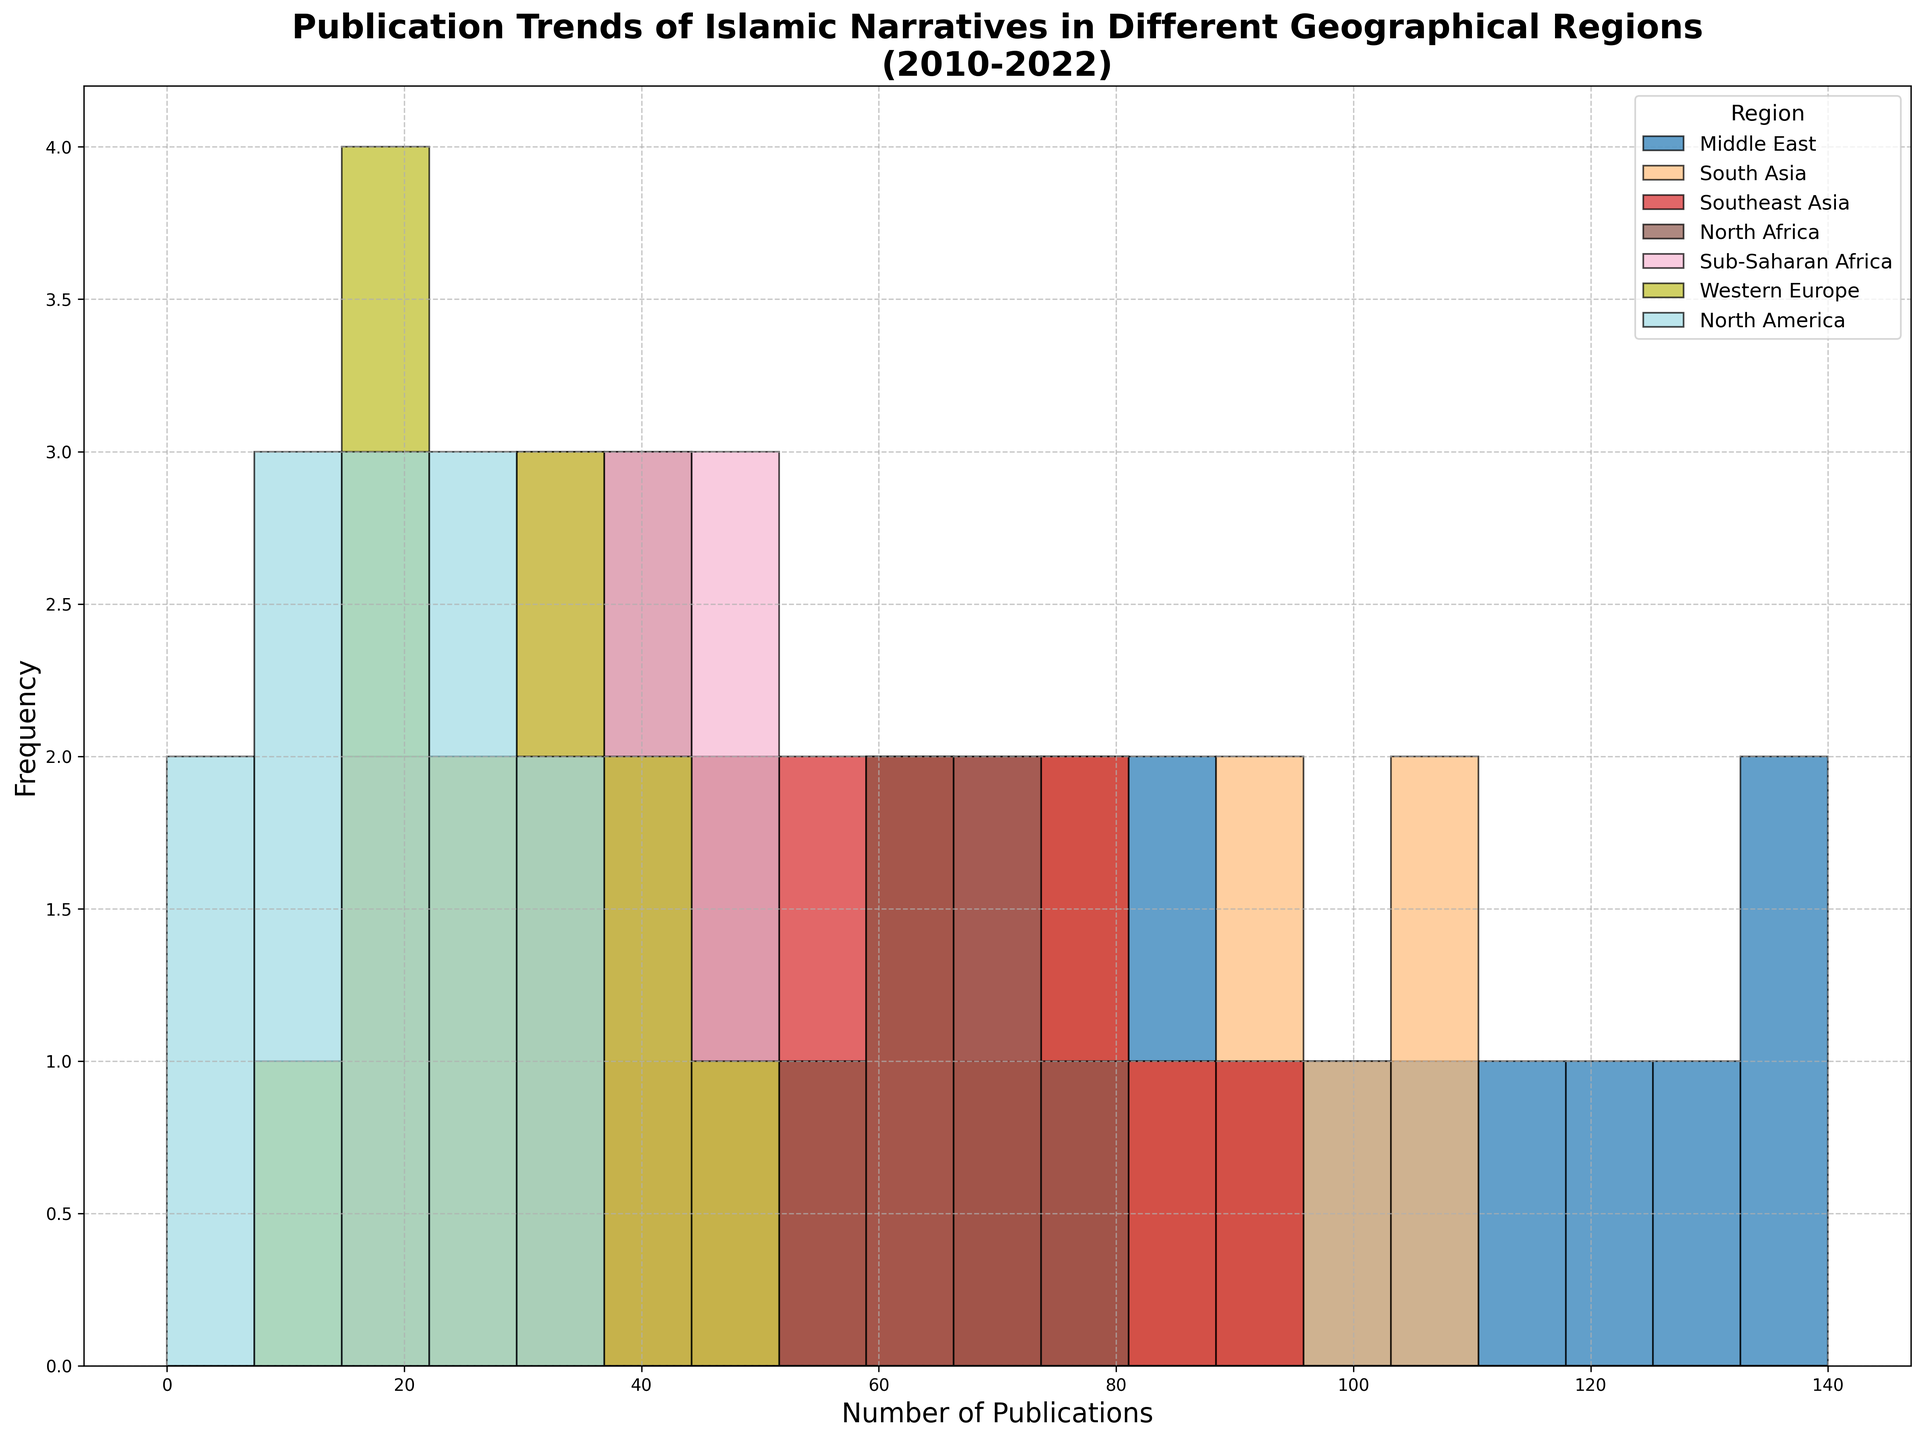What's the most frequent range of publications for the Middle East? To find the most frequent range, observe the height (frequency) of the bins in the histogram for the Middle East. Identify the bin with the highest bar (peak) for that region.
Answer: 120-140 Which region has the second-highest number of publications in the 2010-2022 timeframe? Compare the max number of publications for different regions from the histogram. The Middle East has the highest peak at 140, followed by South Asia with a peak at 110.
Answer: South Asia Is there any region that has a consistently low publication frequency over the years? Look at all the bins with the shortest bars across the entire plot. Western Europe and North America have much lower frequencies compared to others.
Answer: Western Europe and North America What is the range of publications for North Africa? Observe the x-axis range where there are bars representing North Africa. This range starts from the minimum number of publications and ends with the maximum.
Answer: 30-75 Which region shows the highest growth in publications over the years? By comparing the trends in the histogram, look for the region where bars shift significantly rightwards over time. The Middle East shows substantial growth, moving up to 140 publications.
Answer: Middle East What's the least number of publications recorded in Southeast Asia? Find the shortest bar for Southeast Asia on the histogram. This corresponds to the least number of publications.
Answer: 40 Compare the variability in publication trends between Sub-Saharan Africa and North America. Look at the spread of bars for both regions. Sub-Saharan Africa ranges from 20 to 50 while North America ranges from 5 to 35. Assess the spread and the increase in publication counts.
Answer: Sub-Saharan Africa has more variability Which two regions have publication ranges that overlap the most? Identify the ranges of publications for each region and compare their overlaps. Both Middle East and South Asia have a considerable overlap, ranging from 50 to over 100 publications.
Answer: Middle East and South Asia What is the median publication count for South Asia in this period? Identify the publication counts from the histogram for South Asia and calculate the median by sorting these counts. The counts are 50, 55...110. The median is in the middle of this sorted list.
Answer: 75 